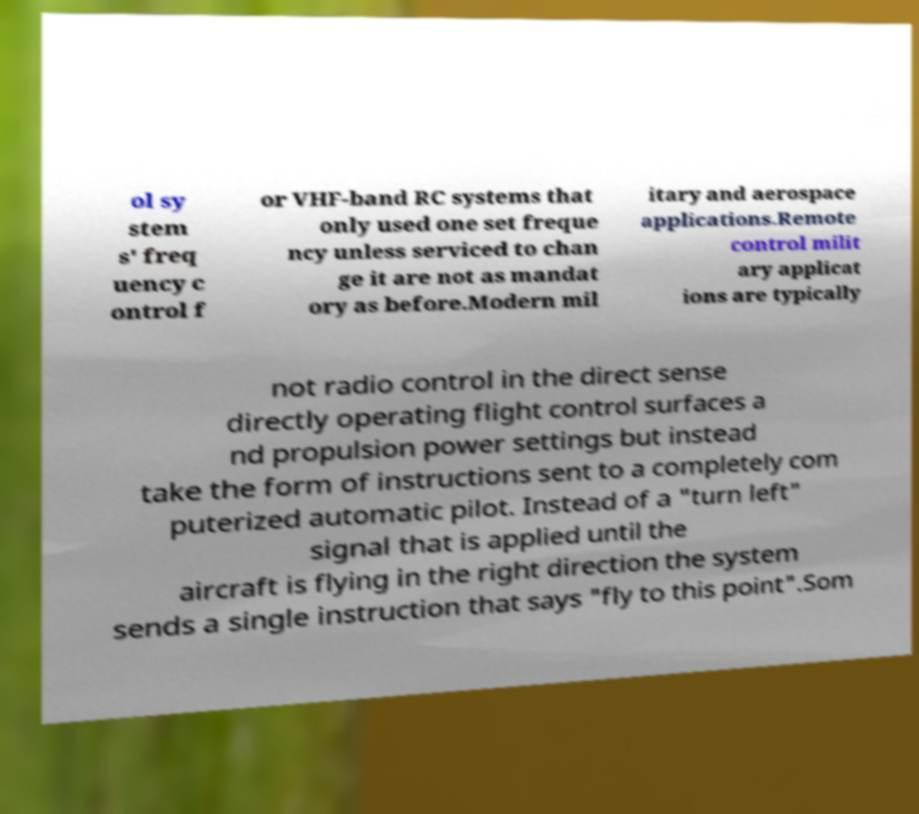Could you extract and type out the text from this image? ol sy stem s' freq uency c ontrol f or VHF-band RC systems that only used one set freque ncy unless serviced to chan ge it are not as mandat ory as before.Modern mil itary and aerospace applications.Remote control milit ary applicat ions are typically not radio control in the direct sense directly operating flight control surfaces a nd propulsion power settings but instead take the form of instructions sent to a completely com puterized automatic pilot. Instead of a "turn left" signal that is applied until the aircraft is flying in the right direction the system sends a single instruction that says "fly to this point".Som 